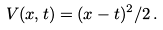<formula> <loc_0><loc_0><loc_500><loc_500>V ( x , t ) = ( x - t ) ^ { 2 } / 2 \, .</formula> 